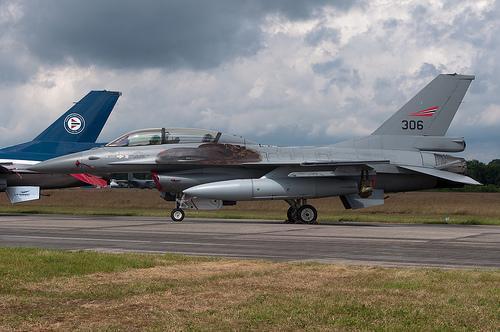How many planes are visible?
Give a very brief answer. 2. 